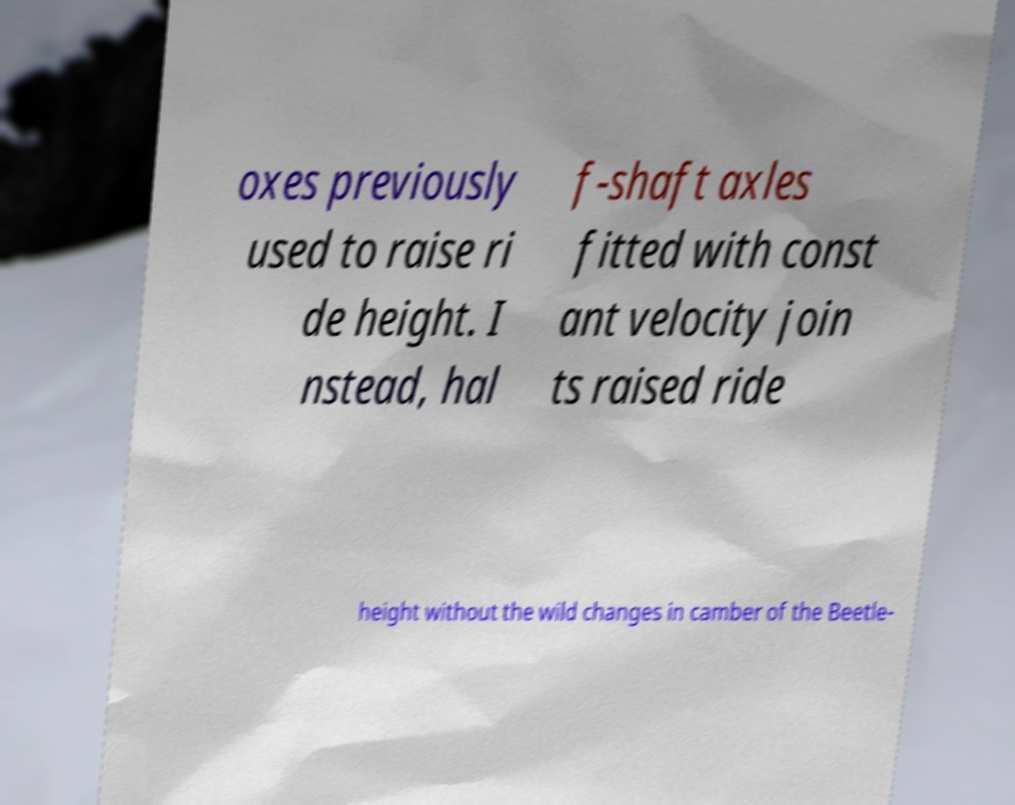For documentation purposes, I need the text within this image transcribed. Could you provide that? oxes previously used to raise ri de height. I nstead, hal f-shaft axles fitted with const ant velocity join ts raised ride height without the wild changes in camber of the Beetle- 